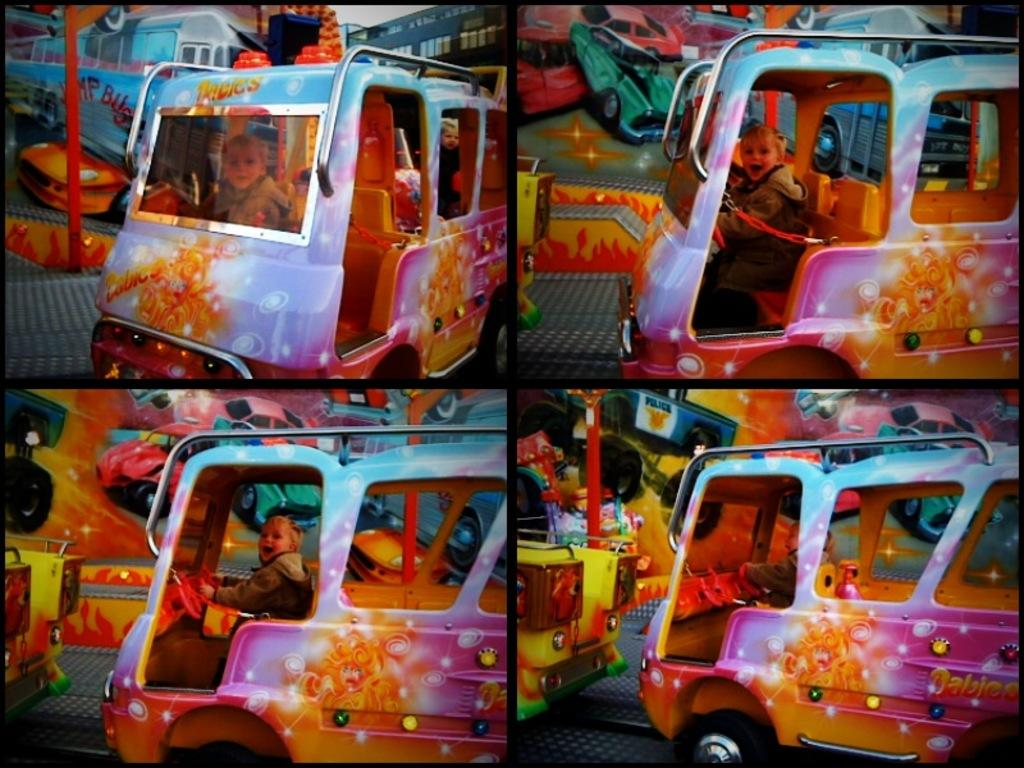What is the main subject of the image? The image contains a collage of photos. What types of vehicles can be seen in the collage? There are vehicles depicted in the collage. What is the baby doing in the image? A baby is sitting in one of the vehicles. How is the baby dressed in the image? The baby is wearing clothes. What type of credit card is the baby holding in the image? There is no credit card present in the image; the baby is sitting in a vehicle and wearing clothes. What angle is the camera positioned at to capture the image? The angle of the camera is not mentioned in the provided facts, but it is not necessary to answer the questions about the image. 